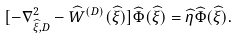Convert formula to latex. <formula><loc_0><loc_0><loc_500><loc_500>[ - \nabla _ { \widehat { \xi } , D } ^ { 2 } - \widehat { W } ^ { ( D ) } ( \widehat { \xi } ) ] \widehat { \Phi } ( \widehat { \xi } ) = \widehat { \eta } \widehat { \Phi } ( \widehat { \xi } ) .</formula> 